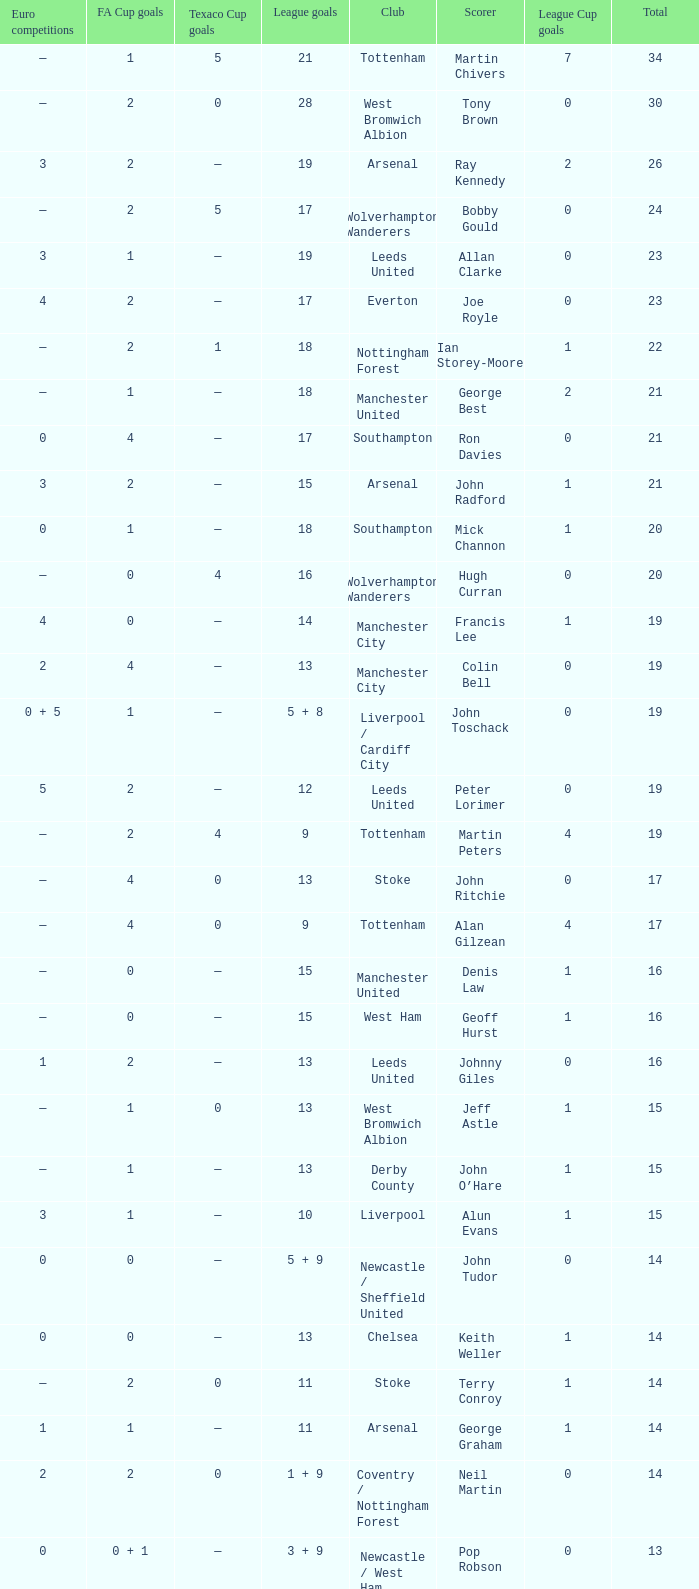What is the total number of Total, when Club is Leeds United, and when League Goals is 13? 1.0. 